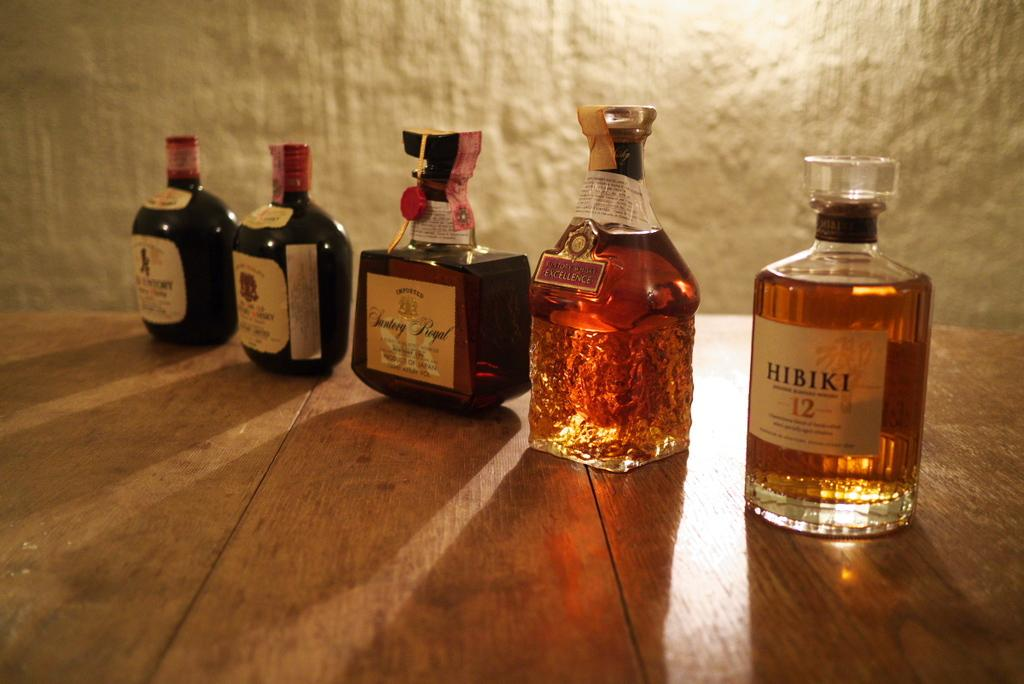<image>
Render a clear and concise summary of the photo. the name Hibiki that is on a whiskey bottle 